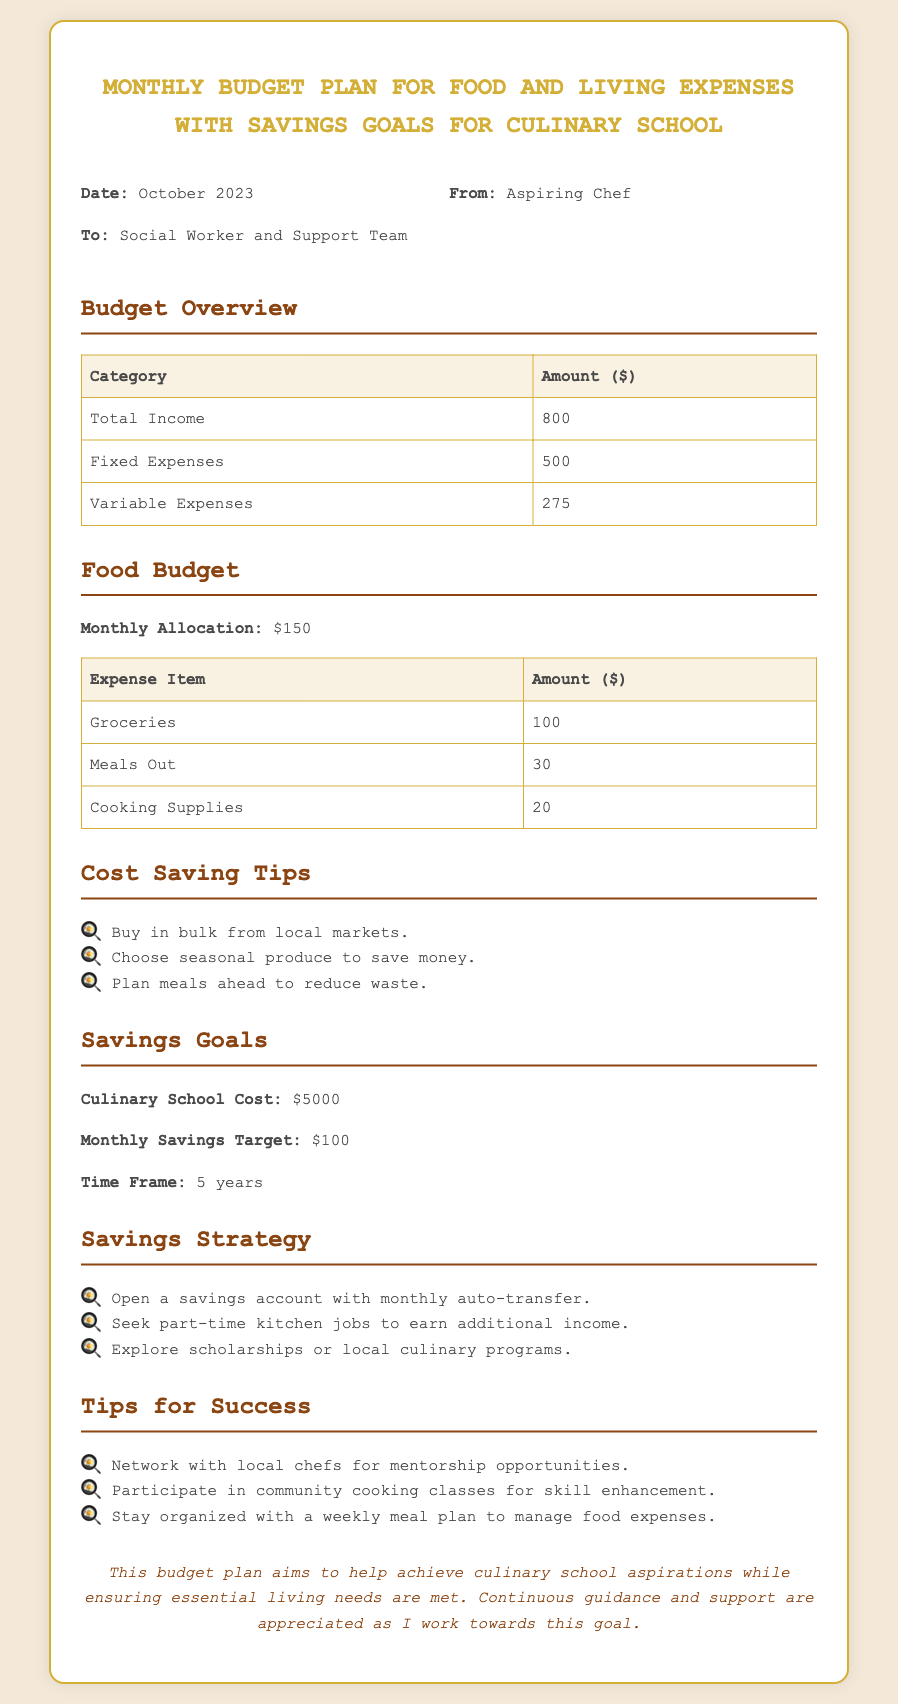What is the total income? The total income is stated in the budget overview section of the document as $800.
Answer: $800 What is the monthly food budget allocation? The document specifies the monthly food budget allocation under the food budget section as $150.
Answer: $150 How much is allocated for groceries? The allocation for groceries is indicated in the food budget table as $100.
Answer: $100 What is the total cost for culinary school? The total cost for culinary school is mentioned in the savings goals section as $5000.
Answer: $5000 What is the monthly savings target? The monthly savings target is outlined in the savings goals section of the document as $100.
Answer: $100 What are two tips for cost savings mentioned? The document lists tips for cost saving under a dedicated section; two of them include buying in bulk and choosing seasonal produce.
Answer: Buy in bulk, choose seasonal produce How long is the time frame to reach the savings goal? The time frame to reach the savings goal is specified in the savings goals section as 5 years.
Answer: 5 years What is one strategy for savings? One savings strategy mentioned is to open a savings account with monthly auto-transfer.
Answer: Open a savings account with monthly auto-transfer Who is the memo addressed to? The memo is addressed to the social worker and support team, as indicated in the header section.
Answer: Social Worker and Support Team 